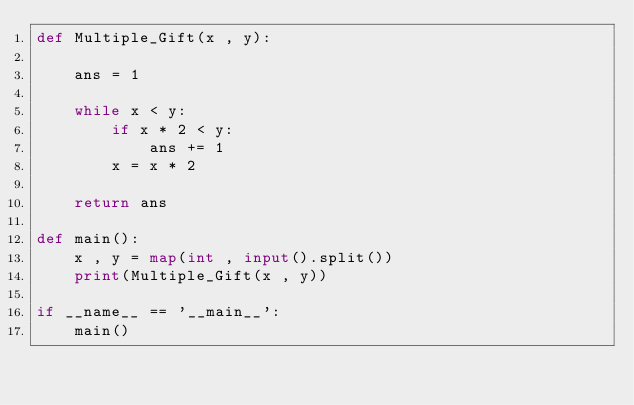Convert code to text. <code><loc_0><loc_0><loc_500><loc_500><_Python_>def Multiple_Gift(x , y):

    ans = 1

    while x < y:
        if x * 2 < y:
            ans += 1
        x = x * 2

    return ans

def main():
    x , y = map(int , input().split())
    print(Multiple_Gift(x , y))

if __name__ == '__main__':
    main()
</code> 